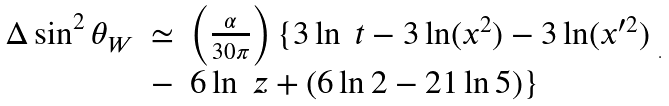Convert formula to latex. <formula><loc_0><loc_0><loc_500><loc_500>\begin{array} { r c l } \Delta \sin ^ { 2 } \theta _ { W } & \simeq & \left ( \frac { \alpha } { 3 0 \pi } \right ) \{ 3 \ln \ t - 3 \ln ( x ^ { 2 } ) - 3 \ln ( x ^ { \prime 2 } ) \strut \\ & - & 6 \ln \ z + ( 6 \ln 2 - 2 1 \ln 5 ) \} \end{array} .</formula> 